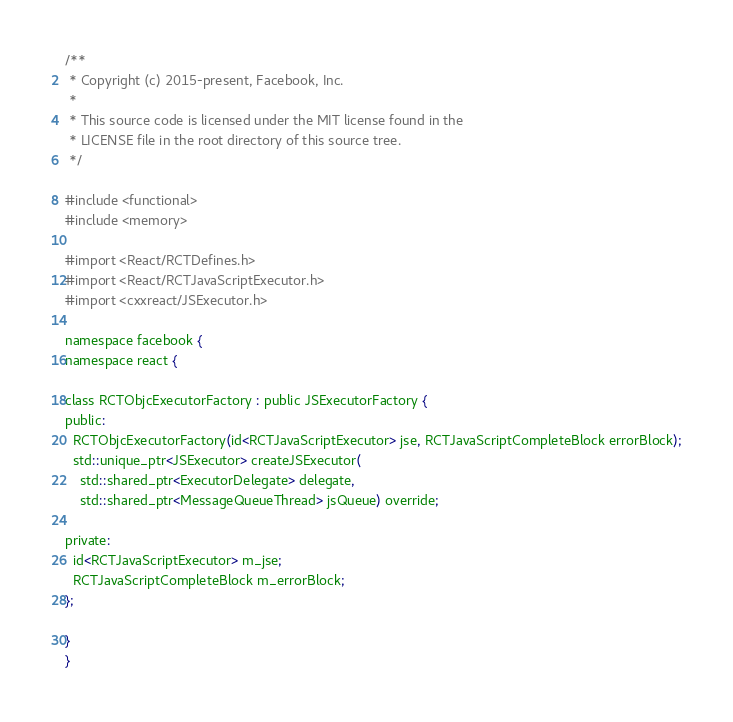<code> <loc_0><loc_0><loc_500><loc_500><_C_>/**
 * Copyright (c) 2015-present, Facebook, Inc.
 *
 * This source code is licensed under the MIT license found in the
 * LICENSE file in the root directory of this source tree.
 */

#include <functional>
#include <memory>

#import <React/RCTDefines.h>
#import <React/RCTJavaScriptExecutor.h>
#import <cxxreact/JSExecutor.h>

namespace facebook {
namespace react {

class RCTObjcExecutorFactory : public JSExecutorFactory {
public:
  RCTObjcExecutorFactory(id<RCTJavaScriptExecutor> jse, RCTJavaScriptCompleteBlock errorBlock);
  std::unique_ptr<JSExecutor> createJSExecutor(
    std::shared_ptr<ExecutorDelegate> delegate,
    std::shared_ptr<MessageQueueThread> jsQueue) override;

private:
  id<RCTJavaScriptExecutor> m_jse;
  RCTJavaScriptCompleteBlock m_errorBlock;
};

}
}
</code> 